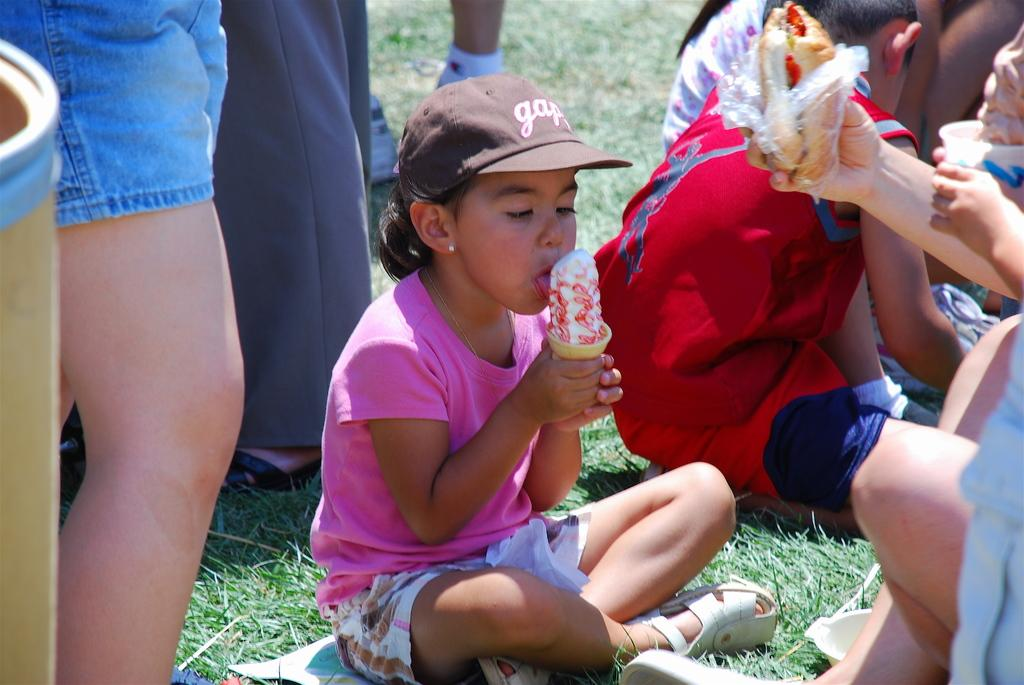<image>
Give a short and clear explanation of the subsequent image. a girl eating icecream wearing a Gap hat 